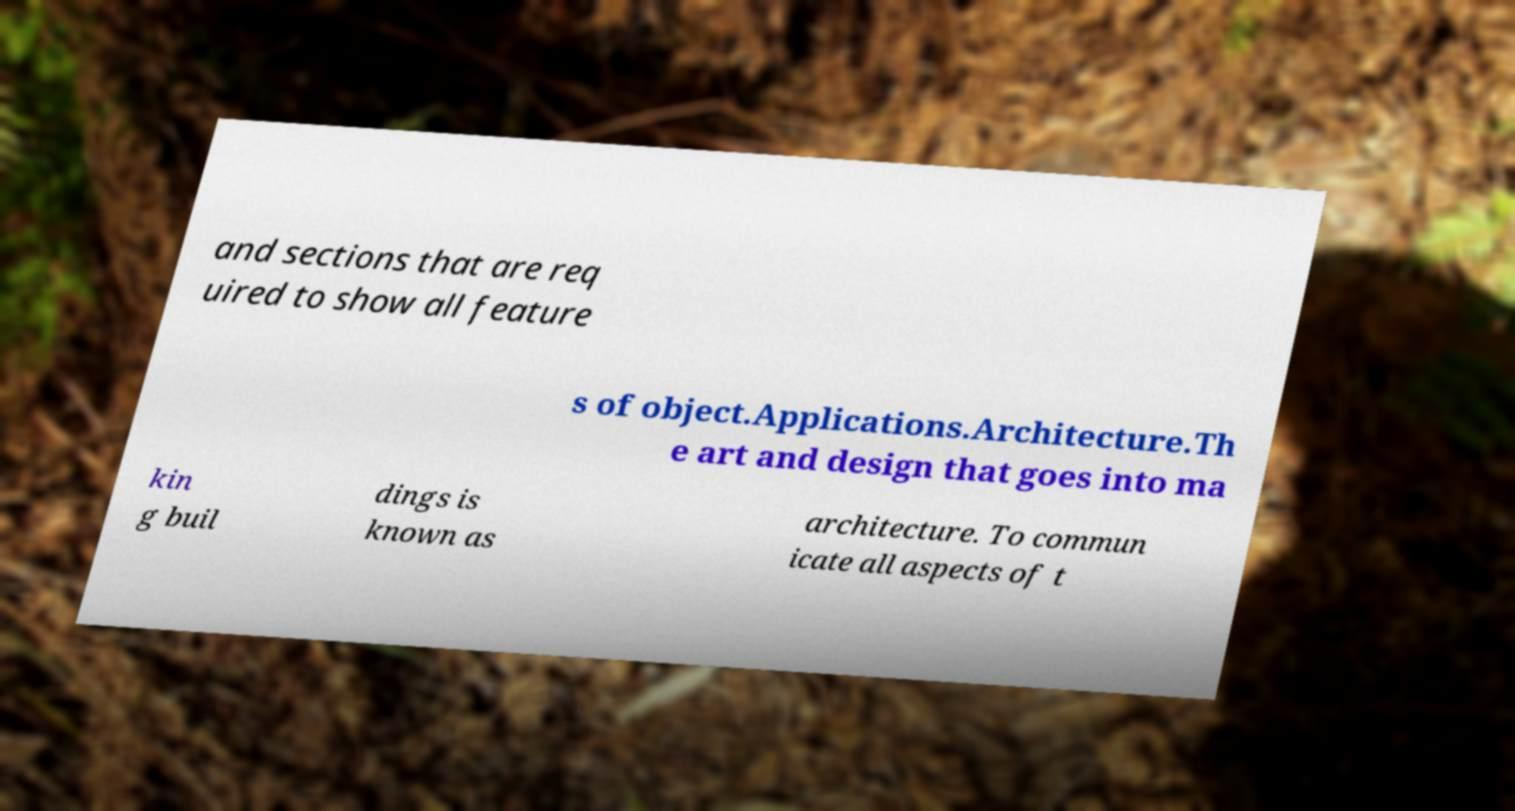There's text embedded in this image that I need extracted. Can you transcribe it verbatim? and sections that are req uired to show all feature s of object.Applications.Architecture.Th e art and design that goes into ma kin g buil dings is known as architecture. To commun icate all aspects of t 